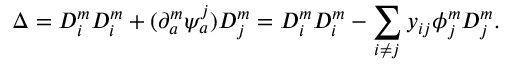Convert formula to latex. <formula><loc_0><loc_0><loc_500><loc_500>\Delta = D _ { i } ^ { m } D _ { i } ^ { m } + ( \partial _ { a } ^ { m } \psi _ { a } ^ { j } ) D _ { j } ^ { m } = D _ { i } ^ { m } D _ { i } ^ { m } - \sum _ { i \neq j } y _ { i j } \phi _ { j } ^ { m } D _ { j } ^ { m } .</formula> 